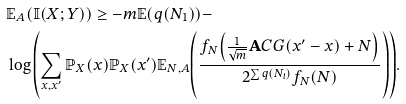Convert formula to latex. <formula><loc_0><loc_0><loc_500><loc_500>& \mathbb { E } _ { A } { \left ( \mathbb { I } ( X ; Y ) \right ) } \geq - m \mathbb { E } { \left ( q ( N _ { 1 } ) \right ) } - \\ & \log { \left ( \sum _ { x , x ^ { \prime } } { \mathbb { P } _ { X } ( x ) \mathbb { P } _ { X } ( x ^ { \prime } ) \mathbb { E } _ { N , A } { \left ( \frac { f _ { N } { \left ( \frac { 1 } { \sqrt { m } } \mathbf A C G ( x ^ { \prime } - x ) + N \right ) } } { 2 ^ { \sum { q ( N _ { i } ) } } f _ { N } ( N ) } \right ) } } \right ) } .</formula> 